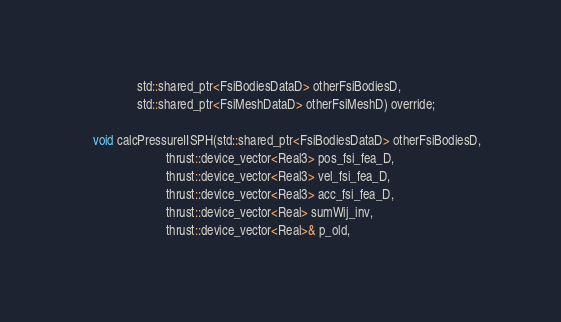Convert code to text. <code><loc_0><loc_0><loc_500><loc_500><_Cuda_>                  std::shared_ptr<FsiBodiesDataD> otherFsiBodiesD,
                  std::shared_ptr<FsiMeshDataD> otherFsiMeshD) override;

    void calcPressureIISPH(std::shared_ptr<FsiBodiesDataD> otherFsiBodiesD,
                           thrust::device_vector<Real3> pos_fsi_fea_D,
                           thrust::device_vector<Real3> vel_fsi_fea_D,
                           thrust::device_vector<Real3> acc_fsi_fea_D,
                           thrust::device_vector<Real> sumWij_inv,
                           thrust::device_vector<Real>& p_old,</code> 